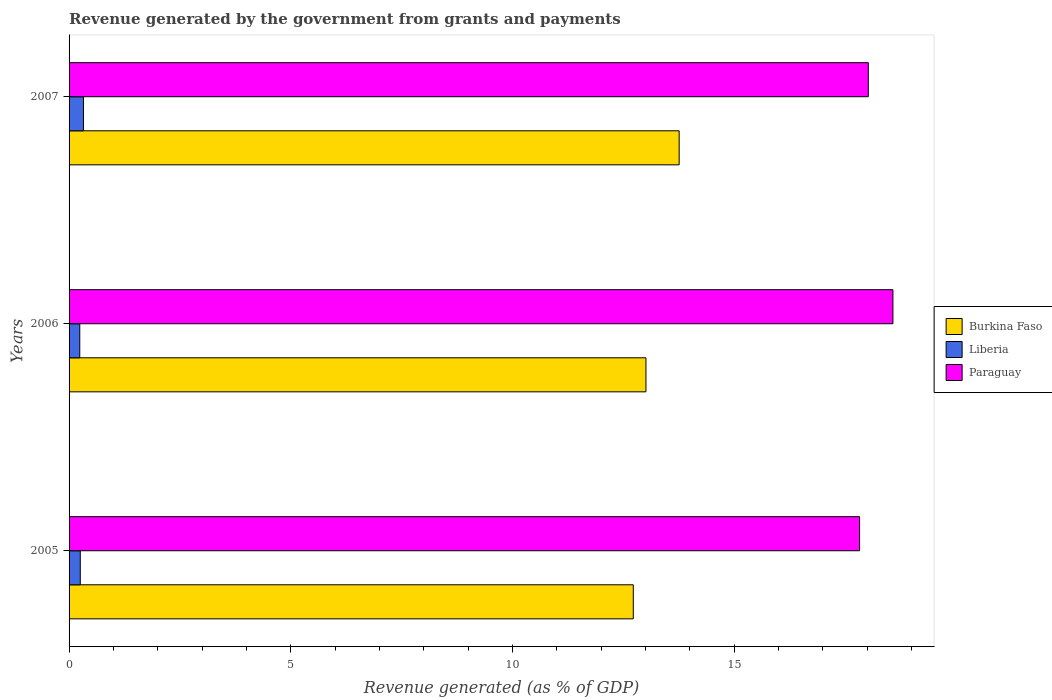How many different coloured bars are there?
Make the answer very short. 3. How many groups of bars are there?
Offer a very short reply. 3. What is the label of the 1st group of bars from the top?
Ensure brevity in your answer.  2007. In how many cases, is the number of bars for a given year not equal to the number of legend labels?
Offer a very short reply. 0. What is the revenue generated by the government in Paraguay in 2007?
Your answer should be compact. 18.03. Across all years, what is the maximum revenue generated by the government in Burkina Faso?
Your answer should be very brief. 13.76. Across all years, what is the minimum revenue generated by the government in Paraguay?
Keep it short and to the point. 17.83. In which year was the revenue generated by the government in Liberia maximum?
Offer a terse response. 2007. In which year was the revenue generated by the government in Liberia minimum?
Make the answer very short. 2006. What is the total revenue generated by the government in Liberia in the graph?
Keep it short and to the point. 0.82. What is the difference between the revenue generated by the government in Paraguay in 2005 and that in 2006?
Ensure brevity in your answer.  -0.75. What is the difference between the revenue generated by the government in Paraguay in 2006 and the revenue generated by the government in Liberia in 2005?
Your answer should be compact. 18.33. What is the average revenue generated by the government in Paraguay per year?
Your answer should be compact. 18.15. In the year 2005, what is the difference between the revenue generated by the government in Liberia and revenue generated by the government in Paraguay?
Your answer should be very brief. -17.58. What is the ratio of the revenue generated by the government in Liberia in 2005 to that in 2006?
Your answer should be compact. 1.05. Is the revenue generated by the government in Burkina Faso in 2005 less than that in 2007?
Give a very brief answer. Yes. Is the difference between the revenue generated by the government in Liberia in 2006 and 2007 greater than the difference between the revenue generated by the government in Paraguay in 2006 and 2007?
Your answer should be very brief. No. What is the difference between the highest and the second highest revenue generated by the government in Paraguay?
Your response must be concise. 0.56. What is the difference between the highest and the lowest revenue generated by the government in Burkina Faso?
Ensure brevity in your answer.  1.03. In how many years, is the revenue generated by the government in Liberia greater than the average revenue generated by the government in Liberia taken over all years?
Give a very brief answer. 1. What does the 1st bar from the top in 2007 represents?
Your answer should be compact. Paraguay. What does the 3rd bar from the bottom in 2007 represents?
Give a very brief answer. Paraguay. Is it the case that in every year, the sum of the revenue generated by the government in Liberia and revenue generated by the government in Burkina Faso is greater than the revenue generated by the government in Paraguay?
Make the answer very short. No. How many bars are there?
Your answer should be compact. 9. Are all the bars in the graph horizontal?
Provide a succinct answer. Yes. How many years are there in the graph?
Make the answer very short. 3. What is the difference between two consecutive major ticks on the X-axis?
Keep it short and to the point. 5. Does the graph contain any zero values?
Ensure brevity in your answer.  No. Does the graph contain grids?
Your answer should be compact. No. What is the title of the graph?
Offer a very short reply. Revenue generated by the government from grants and payments. Does "Serbia" appear as one of the legend labels in the graph?
Provide a short and direct response. No. What is the label or title of the X-axis?
Offer a very short reply. Revenue generated (as % of GDP). What is the Revenue generated (as % of GDP) of Burkina Faso in 2005?
Give a very brief answer. 12.73. What is the Revenue generated (as % of GDP) of Liberia in 2005?
Offer a terse response. 0.25. What is the Revenue generated (as % of GDP) of Paraguay in 2005?
Offer a terse response. 17.83. What is the Revenue generated (as % of GDP) of Burkina Faso in 2006?
Offer a very short reply. 13.01. What is the Revenue generated (as % of GDP) in Liberia in 2006?
Provide a succinct answer. 0.24. What is the Revenue generated (as % of GDP) in Paraguay in 2006?
Your response must be concise. 18.58. What is the Revenue generated (as % of GDP) in Burkina Faso in 2007?
Offer a terse response. 13.76. What is the Revenue generated (as % of GDP) in Liberia in 2007?
Provide a short and direct response. 0.32. What is the Revenue generated (as % of GDP) of Paraguay in 2007?
Provide a short and direct response. 18.03. Across all years, what is the maximum Revenue generated (as % of GDP) of Burkina Faso?
Offer a terse response. 13.76. Across all years, what is the maximum Revenue generated (as % of GDP) in Liberia?
Your response must be concise. 0.32. Across all years, what is the maximum Revenue generated (as % of GDP) in Paraguay?
Provide a short and direct response. 18.58. Across all years, what is the minimum Revenue generated (as % of GDP) in Burkina Faso?
Your answer should be very brief. 12.73. Across all years, what is the minimum Revenue generated (as % of GDP) in Liberia?
Your answer should be compact. 0.24. Across all years, what is the minimum Revenue generated (as % of GDP) in Paraguay?
Offer a very short reply. 17.83. What is the total Revenue generated (as % of GDP) in Burkina Faso in the graph?
Provide a short and direct response. 39.5. What is the total Revenue generated (as % of GDP) in Liberia in the graph?
Provide a short and direct response. 0.82. What is the total Revenue generated (as % of GDP) of Paraguay in the graph?
Provide a short and direct response. 54.44. What is the difference between the Revenue generated (as % of GDP) of Burkina Faso in 2005 and that in 2006?
Provide a succinct answer. -0.29. What is the difference between the Revenue generated (as % of GDP) of Liberia in 2005 and that in 2006?
Give a very brief answer. 0.01. What is the difference between the Revenue generated (as % of GDP) in Paraguay in 2005 and that in 2006?
Offer a terse response. -0.75. What is the difference between the Revenue generated (as % of GDP) in Burkina Faso in 2005 and that in 2007?
Your response must be concise. -1.03. What is the difference between the Revenue generated (as % of GDP) of Liberia in 2005 and that in 2007?
Your response must be concise. -0.07. What is the difference between the Revenue generated (as % of GDP) of Paraguay in 2005 and that in 2007?
Your answer should be compact. -0.2. What is the difference between the Revenue generated (as % of GDP) in Burkina Faso in 2006 and that in 2007?
Your response must be concise. -0.75. What is the difference between the Revenue generated (as % of GDP) in Liberia in 2006 and that in 2007?
Give a very brief answer. -0.08. What is the difference between the Revenue generated (as % of GDP) in Paraguay in 2006 and that in 2007?
Your response must be concise. 0.56. What is the difference between the Revenue generated (as % of GDP) in Burkina Faso in 2005 and the Revenue generated (as % of GDP) in Liberia in 2006?
Your answer should be very brief. 12.48. What is the difference between the Revenue generated (as % of GDP) of Burkina Faso in 2005 and the Revenue generated (as % of GDP) of Paraguay in 2006?
Your response must be concise. -5.86. What is the difference between the Revenue generated (as % of GDP) in Liberia in 2005 and the Revenue generated (as % of GDP) in Paraguay in 2006?
Keep it short and to the point. -18.33. What is the difference between the Revenue generated (as % of GDP) of Burkina Faso in 2005 and the Revenue generated (as % of GDP) of Liberia in 2007?
Ensure brevity in your answer.  12.4. What is the difference between the Revenue generated (as % of GDP) in Burkina Faso in 2005 and the Revenue generated (as % of GDP) in Paraguay in 2007?
Your response must be concise. -5.3. What is the difference between the Revenue generated (as % of GDP) of Liberia in 2005 and the Revenue generated (as % of GDP) of Paraguay in 2007?
Your answer should be compact. -17.77. What is the difference between the Revenue generated (as % of GDP) of Burkina Faso in 2006 and the Revenue generated (as % of GDP) of Liberia in 2007?
Give a very brief answer. 12.69. What is the difference between the Revenue generated (as % of GDP) in Burkina Faso in 2006 and the Revenue generated (as % of GDP) in Paraguay in 2007?
Your response must be concise. -5.02. What is the difference between the Revenue generated (as % of GDP) in Liberia in 2006 and the Revenue generated (as % of GDP) in Paraguay in 2007?
Offer a very short reply. -17.78. What is the average Revenue generated (as % of GDP) in Burkina Faso per year?
Provide a succinct answer. 13.17. What is the average Revenue generated (as % of GDP) of Liberia per year?
Make the answer very short. 0.27. What is the average Revenue generated (as % of GDP) of Paraguay per year?
Make the answer very short. 18.15. In the year 2005, what is the difference between the Revenue generated (as % of GDP) in Burkina Faso and Revenue generated (as % of GDP) in Liberia?
Your answer should be very brief. 12.47. In the year 2005, what is the difference between the Revenue generated (as % of GDP) in Burkina Faso and Revenue generated (as % of GDP) in Paraguay?
Keep it short and to the point. -5.1. In the year 2005, what is the difference between the Revenue generated (as % of GDP) of Liberia and Revenue generated (as % of GDP) of Paraguay?
Your answer should be compact. -17.58. In the year 2006, what is the difference between the Revenue generated (as % of GDP) of Burkina Faso and Revenue generated (as % of GDP) of Liberia?
Your answer should be compact. 12.77. In the year 2006, what is the difference between the Revenue generated (as % of GDP) of Burkina Faso and Revenue generated (as % of GDP) of Paraguay?
Ensure brevity in your answer.  -5.57. In the year 2006, what is the difference between the Revenue generated (as % of GDP) of Liberia and Revenue generated (as % of GDP) of Paraguay?
Make the answer very short. -18.34. In the year 2007, what is the difference between the Revenue generated (as % of GDP) of Burkina Faso and Revenue generated (as % of GDP) of Liberia?
Provide a succinct answer. 13.44. In the year 2007, what is the difference between the Revenue generated (as % of GDP) of Burkina Faso and Revenue generated (as % of GDP) of Paraguay?
Offer a terse response. -4.27. In the year 2007, what is the difference between the Revenue generated (as % of GDP) of Liberia and Revenue generated (as % of GDP) of Paraguay?
Keep it short and to the point. -17.7. What is the ratio of the Revenue generated (as % of GDP) of Burkina Faso in 2005 to that in 2006?
Provide a short and direct response. 0.98. What is the ratio of the Revenue generated (as % of GDP) in Liberia in 2005 to that in 2006?
Offer a terse response. 1.05. What is the ratio of the Revenue generated (as % of GDP) of Paraguay in 2005 to that in 2006?
Give a very brief answer. 0.96. What is the ratio of the Revenue generated (as % of GDP) in Burkina Faso in 2005 to that in 2007?
Provide a short and direct response. 0.92. What is the ratio of the Revenue generated (as % of GDP) in Liberia in 2005 to that in 2007?
Offer a terse response. 0.78. What is the ratio of the Revenue generated (as % of GDP) in Burkina Faso in 2006 to that in 2007?
Offer a very short reply. 0.95. What is the ratio of the Revenue generated (as % of GDP) in Liberia in 2006 to that in 2007?
Make the answer very short. 0.74. What is the ratio of the Revenue generated (as % of GDP) in Paraguay in 2006 to that in 2007?
Keep it short and to the point. 1.03. What is the difference between the highest and the second highest Revenue generated (as % of GDP) of Burkina Faso?
Provide a short and direct response. 0.75. What is the difference between the highest and the second highest Revenue generated (as % of GDP) in Liberia?
Offer a terse response. 0.07. What is the difference between the highest and the second highest Revenue generated (as % of GDP) of Paraguay?
Offer a terse response. 0.56. What is the difference between the highest and the lowest Revenue generated (as % of GDP) in Burkina Faso?
Your answer should be very brief. 1.03. What is the difference between the highest and the lowest Revenue generated (as % of GDP) in Liberia?
Your answer should be compact. 0.08. What is the difference between the highest and the lowest Revenue generated (as % of GDP) in Paraguay?
Give a very brief answer. 0.75. 